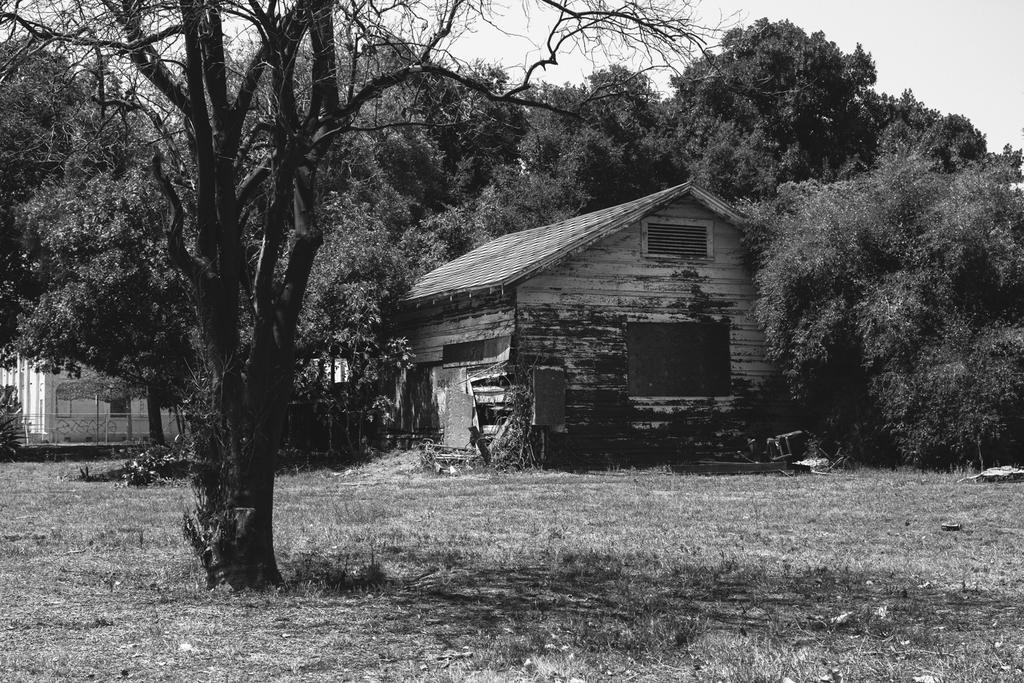How would you summarize this image in a sentence or two? This is a black and white picture. Here we can see trees and houses. This is grass. In the background there is sky. 